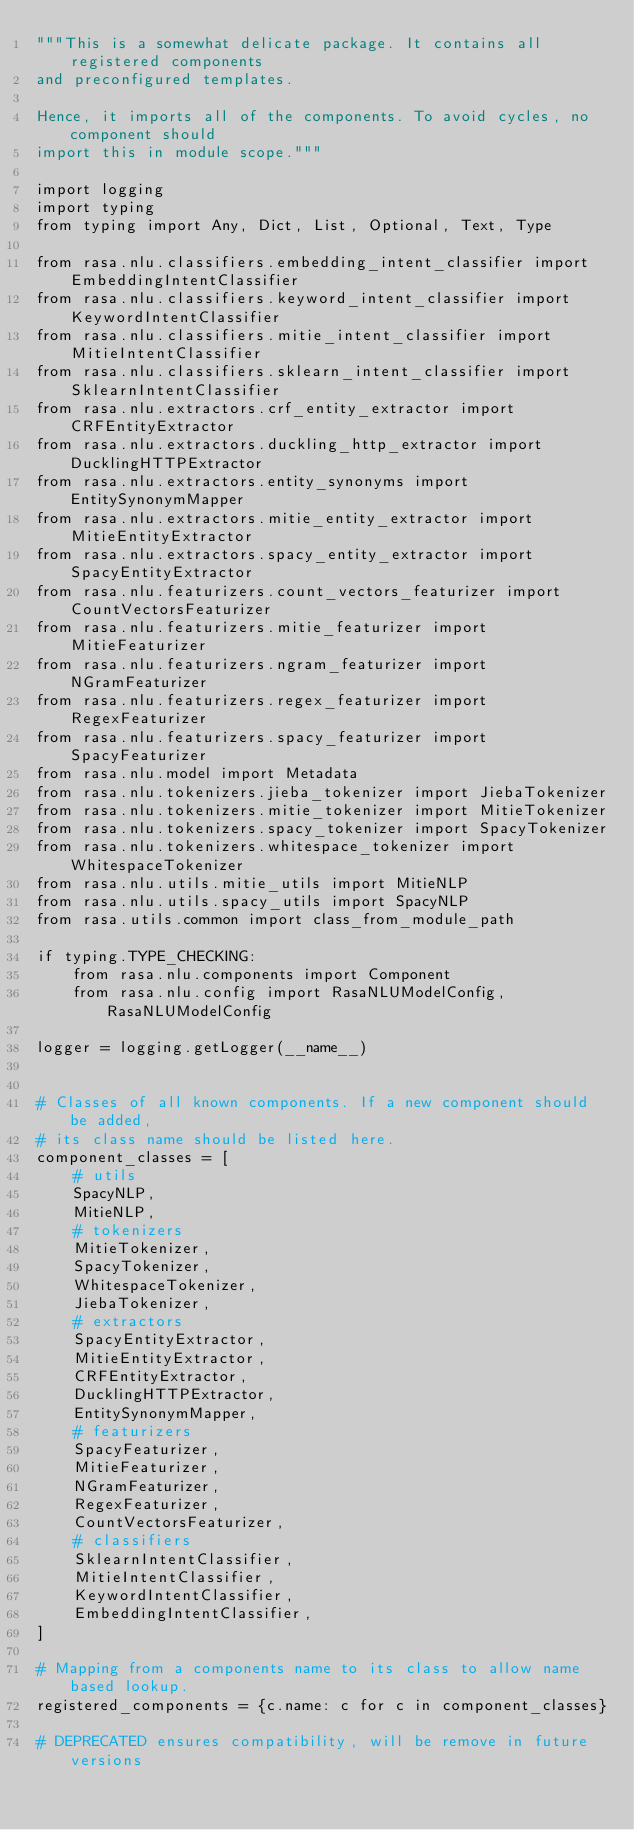<code> <loc_0><loc_0><loc_500><loc_500><_Python_>"""This is a somewhat delicate package. It contains all registered components
and preconfigured templates.

Hence, it imports all of the components. To avoid cycles, no component should
import this in module scope."""

import logging
import typing
from typing import Any, Dict, List, Optional, Text, Type

from rasa.nlu.classifiers.embedding_intent_classifier import EmbeddingIntentClassifier
from rasa.nlu.classifiers.keyword_intent_classifier import KeywordIntentClassifier
from rasa.nlu.classifiers.mitie_intent_classifier import MitieIntentClassifier
from rasa.nlu.classifiers.sklearn_intent_classifier import SklearnIntentClassifier
from rasa.nlu.extractors.crf_entity_extractor import CRFEntityExtractor
from rasa.nlu.extractors.duckling_http_extractor import DucklingHTTPExtractor
from rasa.nlu.extractors.entity_synonyms import EntitySynonymMapper
from rasa.nlu.extractors.mitie_entity_extractor import MitieEntityExtractor
from rasa.nlu.extractors.spacy_entity_extractor import SpacyEntityExtractor
from rasa.nlu.featurizers.count_vectors_featurizer import CountVectorsFeaturizer
from rasa.nlu.featurizers.mitie_featurizer import MitieFeaturizer
from rasa.nlu.featurizers.ngram_featurizer import NGramFeaturizer
from rasa.nlu.featurizers.regex_featurizer import RegexFeaturizer
from rasa.nlu.featurizers.spacy_featurizer import SpacyFeaturizer
from rasa.nlu.model import Metadata
from rasa.nlu.tokenizers.jieba_tokenizer import JiebaTokenizer
from rasa.nlu.tokenizers.mitie_tokenizer import MitieTokenizer
from rasa.nlu.tokenizers.spacy_tokenizer import SpacyTokenizer
from rasa.nlu.tokenizers.whitespace_tokenizer import WhitespaceTokenizer
from rasa.nlu.utils.mitie_utils import MitieNLP
from rasa.nlu.utils.spacy_utils import SpacyNLP
from rasa.utils.common import class_from_module_path

if typing.TYPE_CHECKING:
    from rasa.nlu.components import Component
    from rasa.nlu.config import RasaNLUModelConfig, RasaNLUModelConfig

logger = logging.getLogger(__name__)


# Classes of all known components. If a new component should be added,
# its class name should be listed here.
component_classes = [
    # utils
    SpacyNLP,
    MitieNLP,
    # tokenizers
    MitieTokenizer,
    SpacyTokenizer,
    WhitespaceTokenizer,
    JiebaTokenizer,
    # extractors
    SpacyEntityExtractor,
    MitieEntityExtractor,
    CRFEntityExtractor,
    DucklingHTTPExtractor,
    EntitySynonymMapper,
    # featurizers
    SpacyFeaturizer,
    MitieFeaturizer,
    NGramFeaturizer,
    RegexFeaturizer,
    CountVectorsFeaturizer,
    # classifiers
    SklearnIntentClassifier,
    MitieIntentClassifier,
    KeywordIntentClassifier,
    EmbeddingIntentClassifier,
]

# Mapping from a components name to its class to allow name based lookup.
registered_components = {c.name: c for c in component_classes}

# DEPRECATED ensures compatibility, will be remove in future versions</code> 